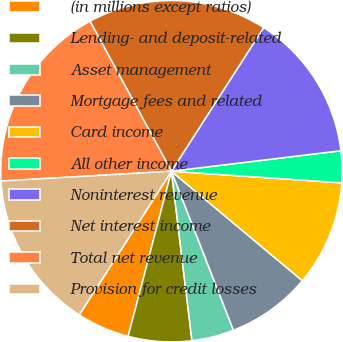Convert chart to OTSL. <chart><loc_0><loc_0><loc_500><loc_500><pie_chart><fcel>(in millions except ratios)<fcel>Lending- and deposit-related<fcel>Asset management<fcel>Mortgage fees and related<fcel>Card income<fcel>All other income<fcel>Noninterest revenue<fcel>Net interest income<fcel>Total net revenue<fcel>Provision for credit losses<nl><fcel>5.0%<fcel>6.0%<fcel>4.0%<fcel>8.0%<fcel>10.0%<fcel>3.0%<fcel>14.0%<fcel>17.0%<fcel>18.0%<fcel>15.0%<nl></chart> 